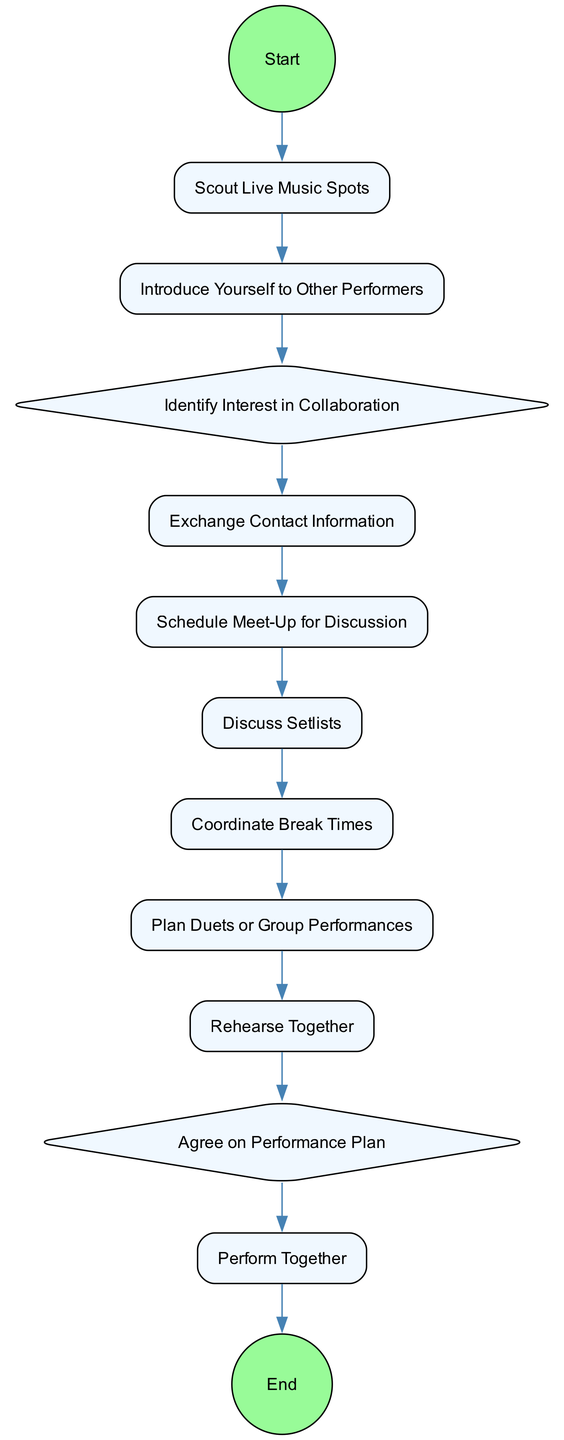What is the first step in the collaboration process? The diagram starts with a "Start Event" labeled "Begin Collaboration Process," which indicates that this is the initial step.
Answer: Begin Collaboration Process How many activity nodes are present in the diagram? By counting the rectangles representing activities, we find there are six distinct activities, excluding start and end events.
Answer: 6 What is the decision point related to identifying interest in collaboration? The decision point in the diagram is titled "Identify Interest in Collaboration," representing a choice that needs to be made during the collaborative process.
Answer: Identify Interest in Collaboration What step follows after discussing setlists? According to the flow of the diagram, the step that directly follows "Discuss Setlists" is "Coordinate Break Times."
Answer: Coordinate Break Times Which activity directly leads to performing together? The diagram shows that "Rehearse Together" is the activity that leads directly into "Perform Together," indicating that rehearsal is a prerequisite for performance.
Answer: Rehearse Together What is the final step in the collaboration process? The last event in the diagram is an "End Event" labeled "End Collaboration Process," which signifies the conclusion of the collaboration.
Answer: End Collaboration Process How many decision points are depicted in the diagram? There are two decision points in the diagram, indicating choices that need to be made during the collaboration process.
Answer: 2 Which activity comes after exchanging contact information? Based on the flow within the diagram, immediately after "Exchange Contact Information," the next activity is "Schedule Meet-Up for Discussion."
Answer: Schedule Meet-Up for Discussion What is the last decision point before performing together? The final decision point before the performance is labeled "Agree on Performance Plan," indicating a critical agreement needed prior to the actual performance.
Answer: Agree on Performance Plan 